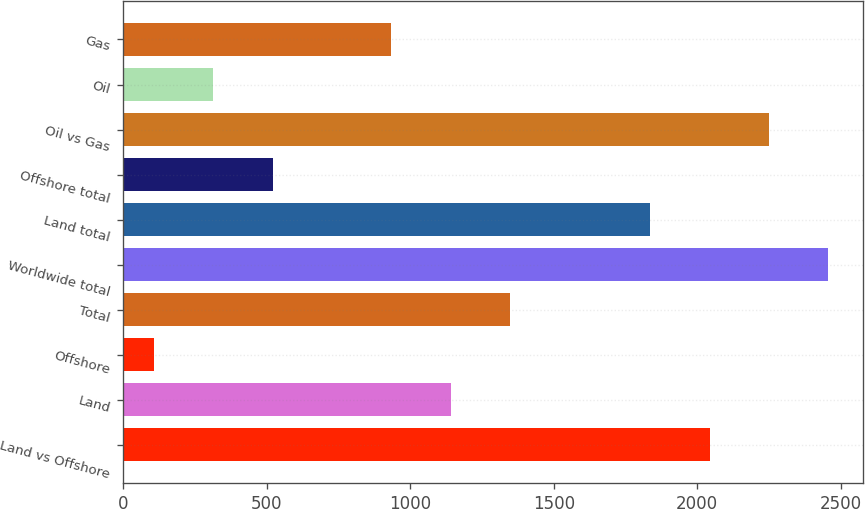<chart> <loc_0><loc_0><loc_500><loc_500><bar_chart><fcel>Land vs Offshore<fcel>Land<fcel>Offshore<fcel>Total<fcel>Worldwide total<fcel>Land total<fcel>Offshore total<fcel>Oil vs Gas<fcel>Oil<fcel>Gas<nl><fcel>2042.6<fcel>1141<fcel>108<fcel>1347.6<fcel>2455.8<fcel>1836<fcel>521.2<fcel>2249.2<fcel>314.6<fcel>934.4<nl></chart> 